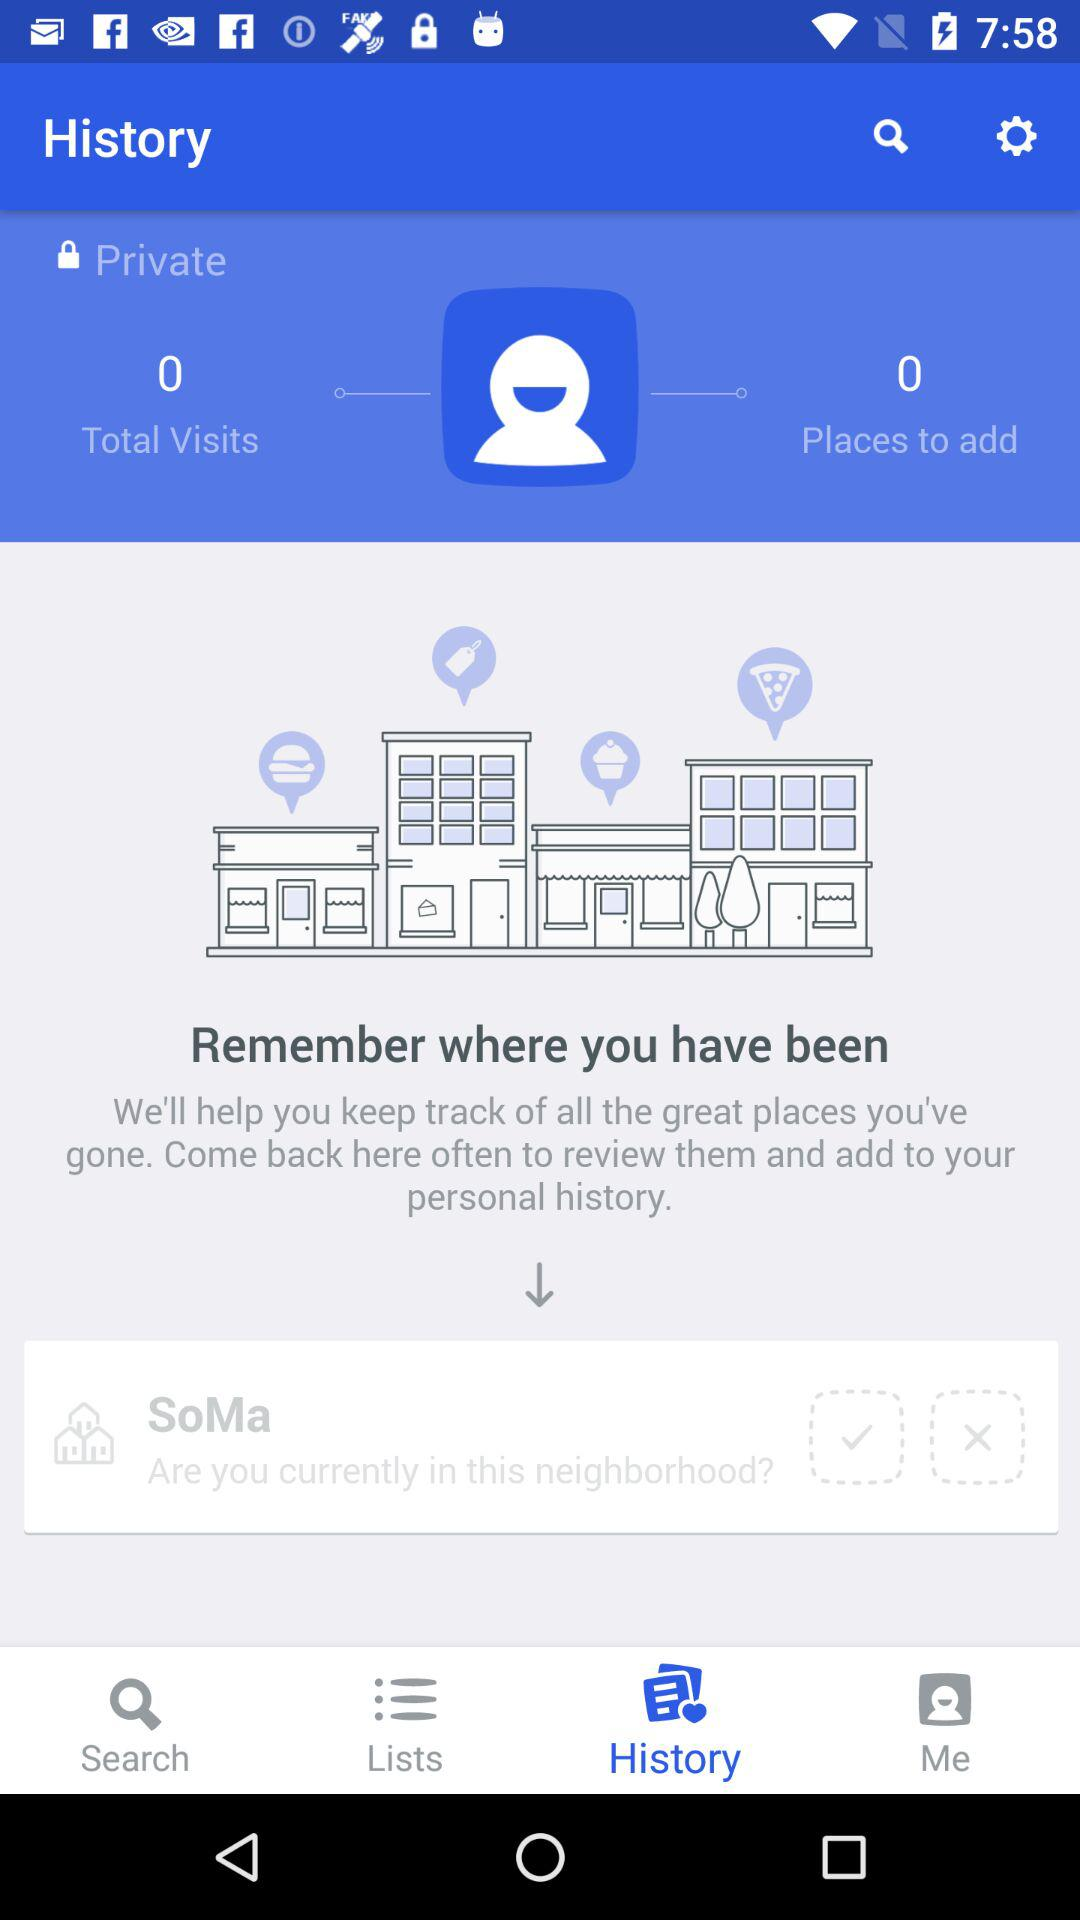How many more places have I been to than are added to my history?
Answer the question using a single word or phrase. 0 